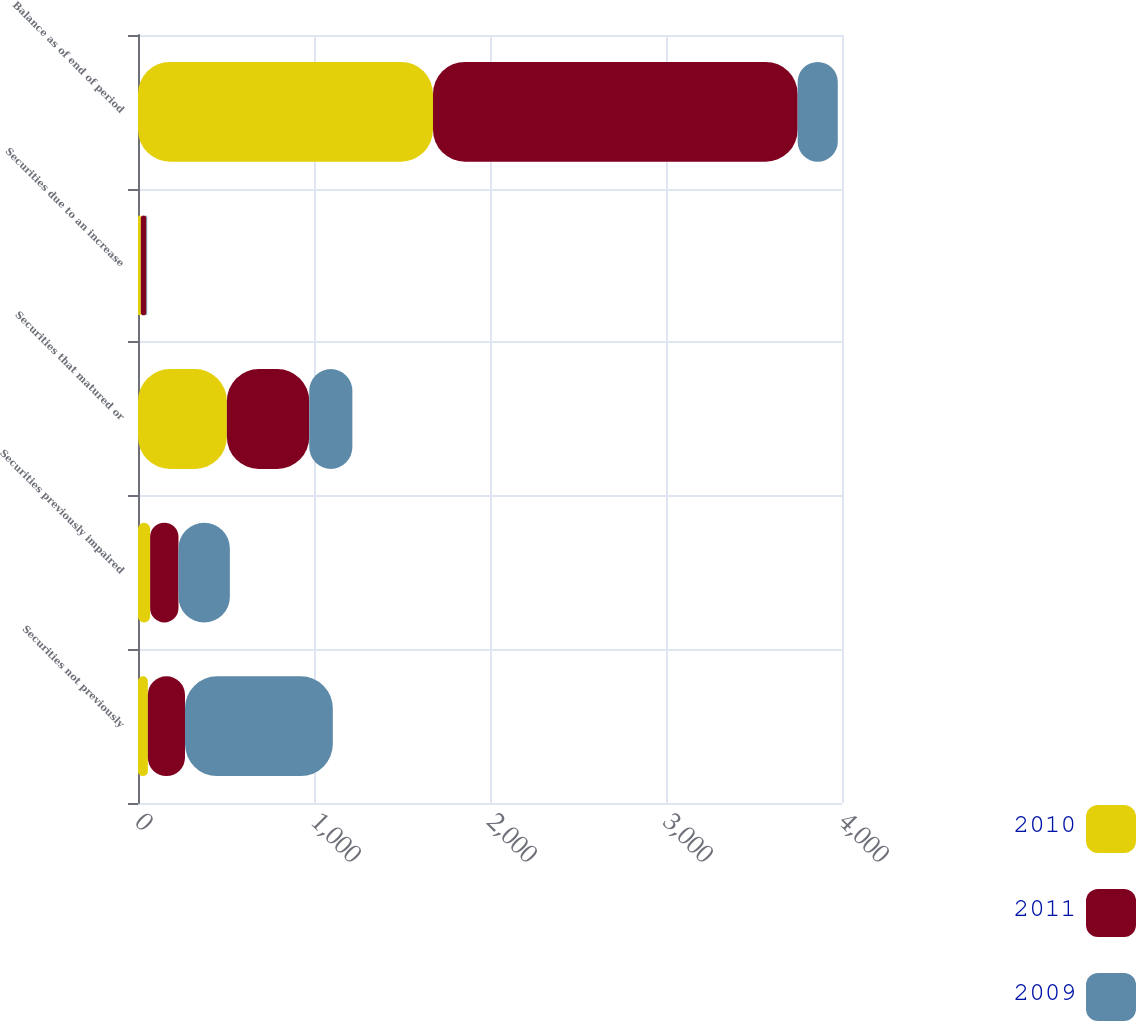Convert chart. <chart><loc_0><loc_0><loc_500><loc_500><stacked_bar_chart><ecel><fcel>Securities not previously<fcel>Securities previously impaired<fcel>Securities that matured or<fcel>Securities due to an increase<fcel>Balance as of end of period<nl><fcel>2010<fcel>56<fcel>69<fcel>505<fcel>16<fcel>1676<nl><fcel>2011<fcel>211<fcel>161<fcel>468<fcel>32<fcel>2072<nl><fcel>2009<fcel>840<fcel>292<fcel>245<fcel>4<fcel>228<nl></chart> 